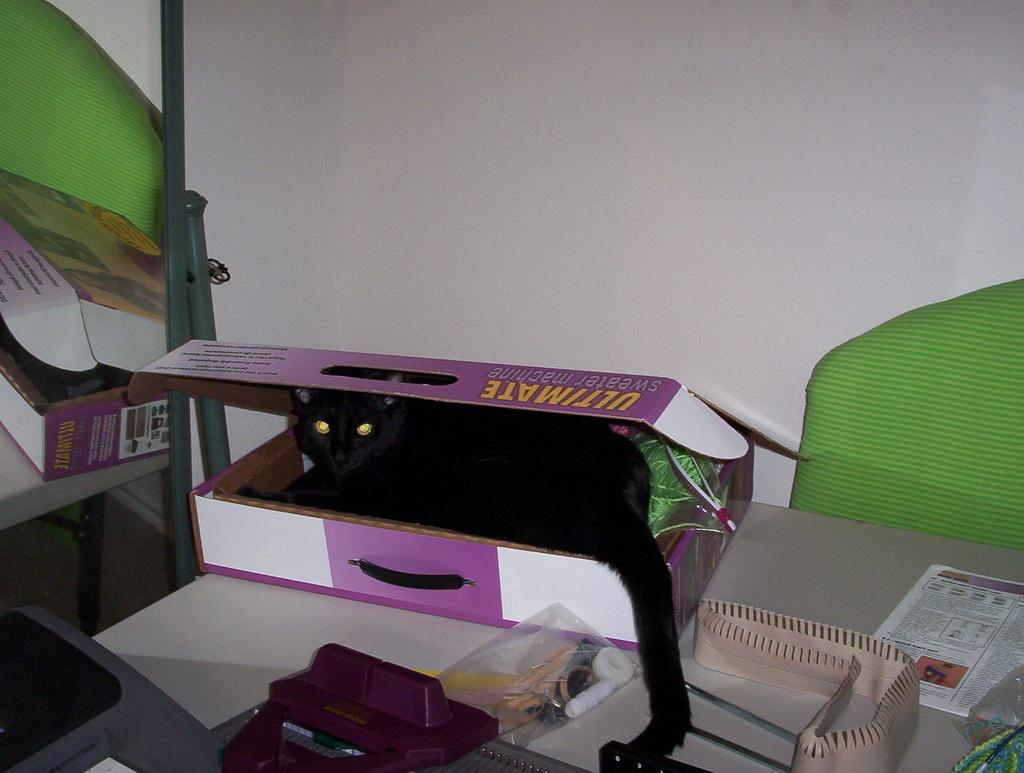What type of animal is in the cardboard box in the image? There is a black color cat in the cardboard box. What is the color of the table where objects are placed? There are objects on a white color table. What can be seen in the background of the image? There is a white wall visible in the background. What song is the cat singing in the cardboard box? Cats do not sing songs, so there is no song being sung by the cat in the image. 